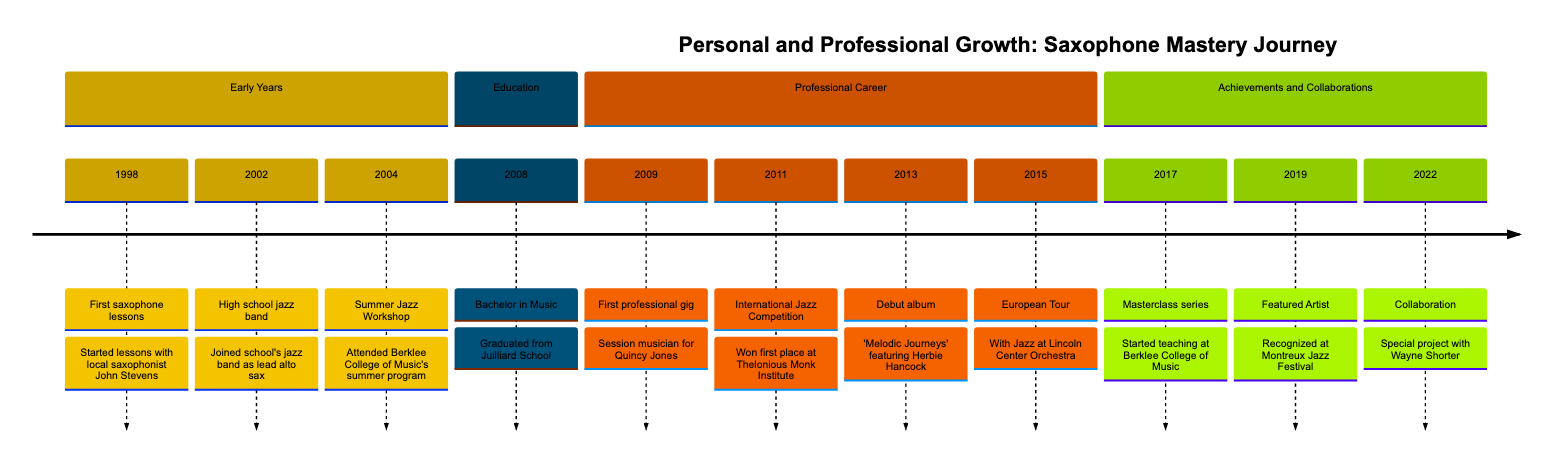What year did you have your first saxophone lessons? According to the timeline, the first saxophone lessons occurred under the event labeled "First saxophone lessons," which is dated 1998. Therefore, the year is directly referenced within that entry.
Answer: 1998 Who was your first saxophone instructor? The first saxophone lessons were started with a local saxophonist named John Stevens. This detail is included in the event description for the first lesson in 1998.
Answer: John Stevens What was the first professional gig? The timeline specifies that the first professional gig was as a session musician for Quincy Jones in 2009. This information is explicitly stated under the related event.
Answer: Session musician for Quincy Jones Which year did you win the International Jazz Competition? The timeline highlights that the win at the International Jazz Competition occurred in 2011, as indicated by the event listing. This allows us to find the specific year of the achievement.
Answer: 2011 What significant collaboration occurred in 2013? The significant collaboration mentioned in 2013 involved the release of the debut album "Melodic Journeys," which features collaboration with Herbie Hancock. This specific collaboration is part of the event description for that year.
Answer: Collaboration with Herbie Hancock In what context did you start a masterclass series? The masterclass series was started at Berklee College of Music in 2017, as indicated in the timeline detailing that event. It reflects the educational initiative undertaken during that year.
Answer: Berklee College of Music What is the latest collaboration mentioned in the timeline? The timeline indicates that the latest collaboration is with Wayne Shorter in 2022, as explicitly stated in the relevant event entry. This is the final collaboration described in the sequence of events.
Answer: Collaboration with Wayne Shorter How many years were there between your first professional gig and winning the International Jazz Competition? By counting the years in the timeline, the first professional gig occurred in 2009 and the international competition win was in 2011. So, the difference between these two years is two years.
Answer: 2 years What event is associated with the European Tour? The timeline specifies the event associated with the European Tour as occurring in 2015. The entry provides the detail that it was with the Jazz at Lincoln Center Orchestra. This is the event linked with the tour.
Answer: With Jazz at Lincoln Center Orchestra 